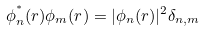<formula> <loc_0><loc_0><loc_500><loc_500>\phi _ { n } ^ { ^ { * } } ( r ) \phi _ { m } ( r ) = | \phi _ { n } ( r ) | ^ { 2 } \delta _ { n , m }</formula> 